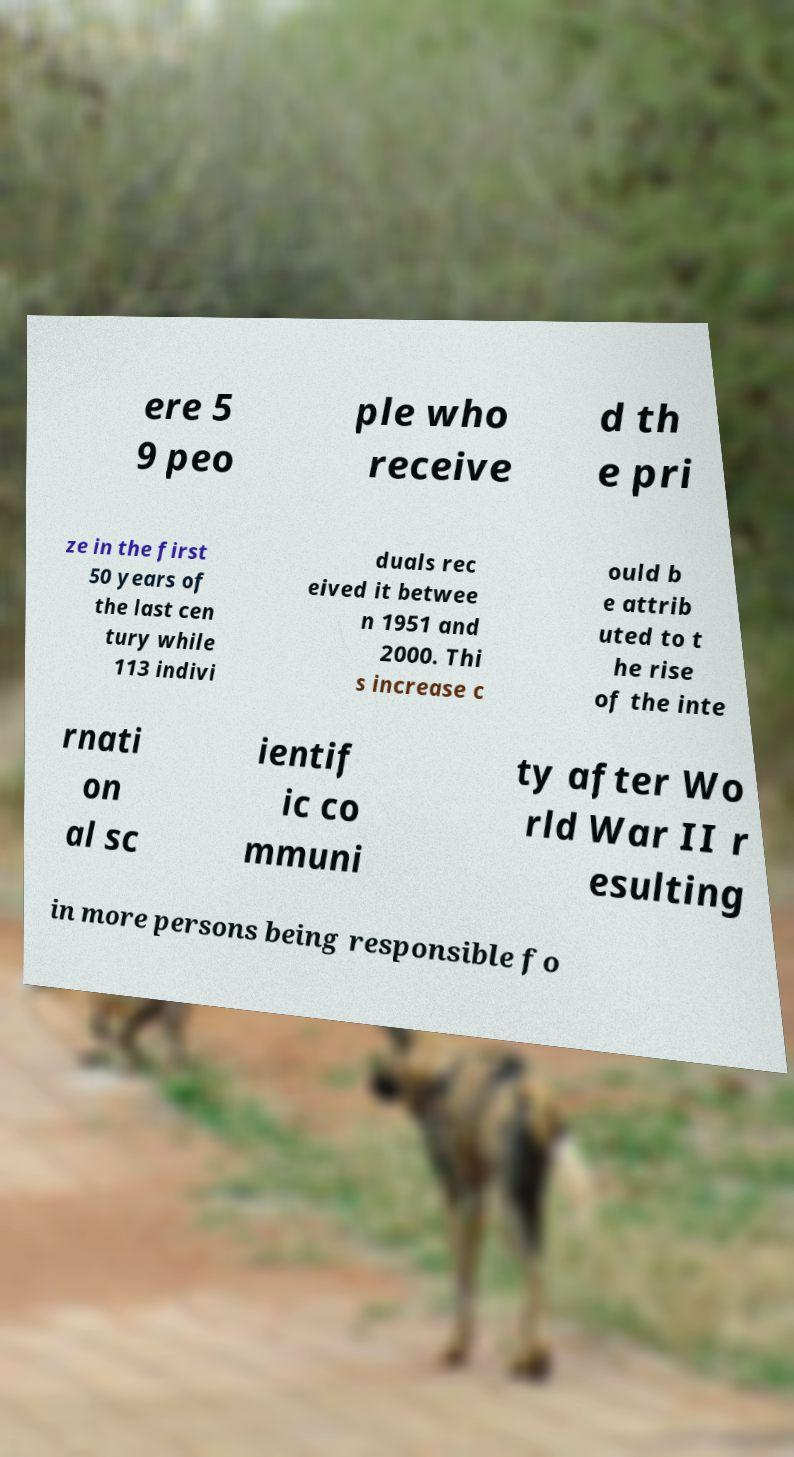Could you assist in decoding the text presented in this image and type it out clearly? ere 5 9 peo ple who receive d th e pri ze in the first 50 years of the last cen tury while 113 indivi duals rec eived it betwee n 1951 and 2000. Thi s increase c ould b e attrib uted to t he rise of the inte rnati on al sc ientif ic co mmuni ty after Wo rld War II r esulting in more persons being responsible fo 